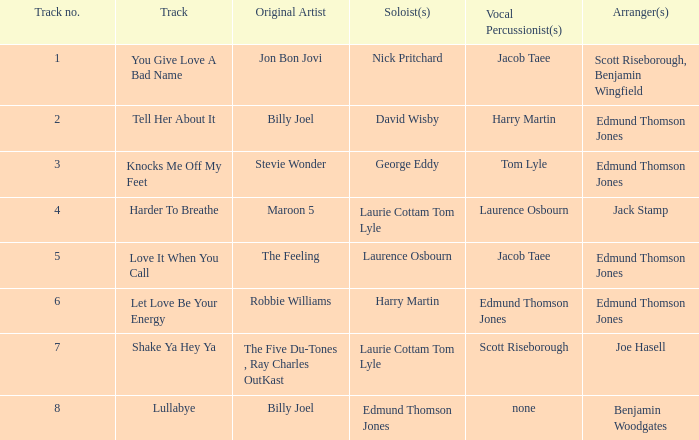Which artist(s) first created track number 6? Robbie Williams. 